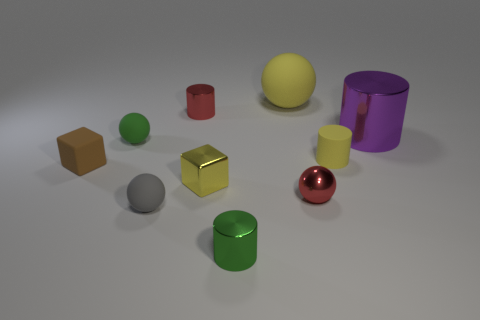Is there anything else that has the same size as the gray object?
Make the answer very short. Yes. There is a large cylinder that is the same material as the red ball; what is its color?
Keep it short and to the point. Purple. What number of cylinders are either tiny brown things or tiny red objects?
Provide a short and direct response. 1. What number of things are either yellow shiny spheres or yellow objects that are in front of the purple cylinder?
Make the answer very short. 2. Is there a big yellow rubber thing?
Your response must be concise. Yes. How many matte spheres have the same color as the metallic cube?
Give a very brief answer. 1. What material is the cylinder that is the same color as the large matte thing?
Your response must be concise. Rubber. There is a green object that is in front of the red metal object in front of the tiny red shiny cylinder; what is its size?
Offer a very short reply. Small. Are there any tiny green spheres made of the same material as the small brown thing?
Offer a very short reply. Yes. There is a green cylinder that is the same size as the yellow metal object; what is its material?
Your answer should be very brief. Metal. 